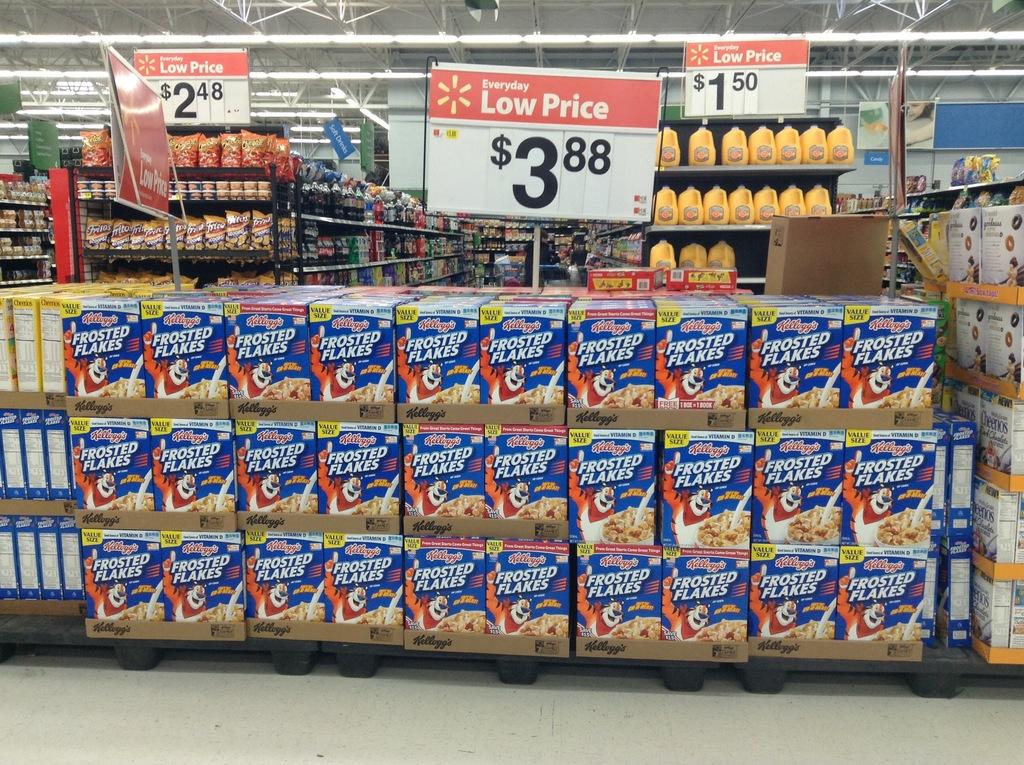What is the brand name cereal shown?
Give a very brief answer. Frosted flakes. 